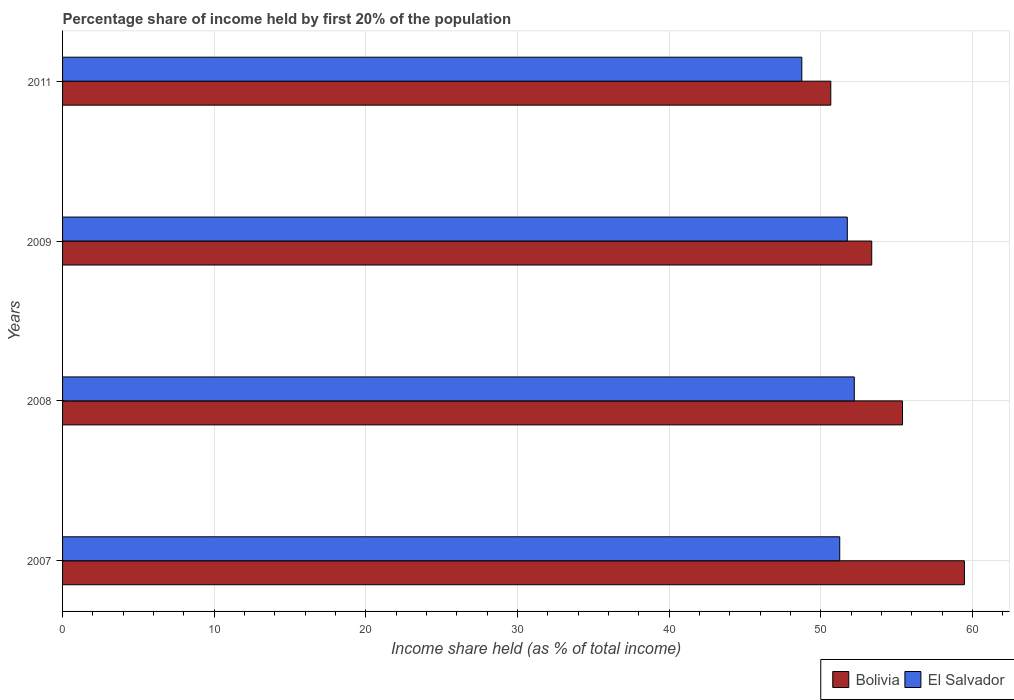How many groups of bars are there?
Ensure brevity in your answer.  4. How many bars are there on the 4th tick from the top?
Offer a very short reply. 2. How many bars are there on the 2nd tick from the bottom?
Your answer should be compact. 2. In how many cases, is the number of bars for a given year not equal to the number of legend labels?
Give a very brief answer. 0. What is the share of income held by first 20% of the population in El Salvador in 2007?
Keep it short and to the point. 51.24. Across all years, what is the maximum share of income held by first 20% of the population in El Salvador?
Offer a very short reply. 52.2. Across all years, what is the minimum share of income held by first 20% of the population in El Salvador?
Your answer should be compact. 48.74. What is the total share of income held by first 20% of the population in Bolivia in the graph?
Your response must be concise. 218.84. What is the difference between the share of income held by first 20% of the population in El Salvador in 2009 and that in 2011?
Provide a short and direct response. 3. What is the difference between the share of income held by first 20% of the population in El Salvador in 2009 and the share of income held by first 20% of the population in Bolivia in 2008?
Ensure brevity in your answer.  -3.64. What is the average share of income held by first 20% of the population in Bolivia per year?
Provide a short and direct response. 54.71. In the year 2009, what is the difference between the share of income held by first 20% of the population in Bolivia and share of income held by first 20% of the population in El Salvador?
Offer a very short reply. 1.61. In how many years, is the share of income held by first 20% of the population in El Salvador greater than 46 %?
Keep it short and to the point. 4. What is the ratio of the share of income held by first 20% of the population in Bolivia in 2008 to that in 2011?
Give a very brief answer. 1.09. Is the share of income held by first 20% of the population in El Salvador in 2007 less than that in 2008?
Your response must be concise. Yes. What is the difference between the highest and the second highest share of income held by first 20% of the population in Bolivia?
Provide a succinct answer. 4.08. What is the difference between the highest and the lowest share of income held by first 20% of the population in Bolivia?
Ensure brevity in your answer.  8.81. Is the sum of the share of income held by first 20% of the population in Bolivia in 2009 and 2011 greater than the maximum share of income held by first 20% of the population in El Salvador across all years?
Your answer should be very brief. Yes. What does the 2nd bar from the top in 2007 represents?
Your response must be concise. Bolivia. How many years are there in the graph?
Provide a short and direct response. 4. Are the values on the major ticks of X-axis written in scientific E-notation?
Keep it short and to the point. No. Does the graph contain any zero values?
Provide a short and direct response. No. Does the graph contain grids?
Keep it short and to the point. Yes. Where does the legend appear in the graph?
Ensure brevity in your answer.  Bottom right. How many legend labels are there?
Provide a succinct answer. 2. What is the title of the graph?
Your answer should be compact. Percentage share of income held by first 20% of the population. What is the label or title of the X-axis?
Your response must be concise. Income share held (as % of total income). What is the Income share held (as % of total income) in Bolivia in 2007?
Your answer should be compact. 59.46. What is the Income share held (as % of total income) of El Salvador in 2007?
Provide a succinct answer. 51.24. What is the Income share held (as % of total income) in Bolivia in 2008?
Provide a succinct answer. 55.38. What is the Income share held (as % of total income) in El Salvador in 2008?
Provide a succinct answer. 52.2. What is the Income share held (as % of total income) in Bolivia in 2009?
Your answer should be very brief. 53.35. What is the Income share held (as % of total income) in El Salvador in 2009?
Your answer should be compact. 51.74. What is the Income share held (as % of total income) of Bolivia in 2011?
Your answer should be very brief. 50.65. What is the Income share held (as % of total income) in El Salvador in 2011?
Keep it short and to the point. 48.74. Across all years, what is the maximum Income share held (as % of total income) in Bolivia?
Offer a very short reply. 59.46. Across all years, what is the maximum Income share held (as % of total income) of El Salvador?
Provide a succinct answer. 52.2. Across all years, what is the minimum Income share held (as % of total income) in Bolivia?
Your answer should be compact. 50.65. Across all years, what is the minimum Income share held (as % of total income) of El Salvador?
Provide a short and direct response. 48.74. What is the total Income share held (as % of total income) in Bolivia in the graph?
Your response must be concise. 218.84. What is the total Income share held (as % of total income) of El Salvador in the graph?
Offer a terse response. 203.92. What is the difference between the Income share held (as % of total income) in Bolivia in 2007 and that in 2008?
Provide a short and direct response. 4.08. What is the difference between the Income share held (as % of total income) of El Salvador in 2007 and that in 2008?
Your answer should be compact. -0.96. What is the difference between the Income share held (as % of total income) in Bolivia in 2007 and that in 2009?
Provide a short and direct response. 6.11. What is the difference between the Income share held (as % of total income) in El Salvador in 2007 and that in 2009?
Make the answer very short. -0.5. What is the difference between the Income share held (as % of total income) in Bolivia in 2007 and that in 2011?
Make the answer very short. 8.81. What is the difference between the Income share held (as % of total income) of Bolivia in 2008 and that in 2009?
Provide a short and direct response. 2.03. What is the difference between the Income share held (as % of total income) of El Salvador in 2008 and that in 2009?
Provide a short and direct response. 0.46. What is the difference between the Income share held (as % of total income) of Bolivia in 2008 and that in 2011?
Offer a very short reply. 4.73. What is the difference between the Income share held (as % of total income) in El Salvador in 2008 and that in 2011?
Keep it short and to the point. 3.46. What is the difference between the Income share held (as % of total income) of El Salvador in 2009 and that in 2011?
Provide a succinct answer. 3. What is the difference between the Income share held (as % of total income) in Bolivia in 2007 and the Income share held (as % of total income) in El Salvador in 2008?
Offer a very short reply. 7.26. What is the difference between the Income share held (as % of total income) in Bolivia in 2007 and the Income share held (as % of total income) in El Salvador in 2009?
Give a very brief answer. 7.72. What is the difference between the Income share held (as % of total income) in Bolivia in 2007 and the Income share held (as % of total income) in El Salvador in 2011?
Ensure brevity in your answer.  10.72. What is the difference between the Income share held (as % of total income) in Bolivia in 2008 and the Income share held (as % of total income) in El Salvador in 2009?
Offer a terse response. 3.64. What is the difference between the Income share held (as % of total income) in Bolivia in 2008 and the Income share held (as % of total income) in El Salvador in 2011?
Offer a very short reply. 6.64. What is the difference between the Income share held (as % of total income) of Bolivia in 2009 and the Income share held (as % of total income) of El Salvador in 2011?
Offer a very short reply. 4.61. What is the average Income share held (as % of total income) of Bolivia per year?
Your answer should be very brief. 54.71. What is the average Income share held (as % of total income) in El Salvador per year?
Your answer should be very brief. 50.98. In the year 2007, what is the difference between the Income share held (as % of total income) in Bolivia and Income share held (as % of total income) in El Salvador?
Offer a very short reply. 8.22. In the year 2008, what is the difference between the Income share held (as % of total income) in Bolivia and Income share held (as % of total income) in El Salvador?
Offer a very short reply. 3.18. In the year 2009, what is the difference between the Income share held (as % of total income) in Bolivia and Income share held (as % of total income) in El Salvador?
Give a very brief answer. 1.61. In the year 2011, what is the difference between the Income share held (as % of total income) in Bolivia and Income share held (as % of total income) in El Salvador?
Provide a short and direct response. 1.91. What is the ratio of the Income share held (as % of total income) of Bolivia in 2007 to that in 2008?
Your response must be concise. 1.07. What is the ratio of the Income share held (as % of total income) of El Salvador in 2007 to that in 2008?
Provide a succinct answer. 0.98. What is the ratio of the Income share held (as % of total income) of Bolivia in 2007 to that in 2009?
Make the answer very short. 1.11. What is the ratio of the Income share held (as % of total income) of El Salvador in 2007 to that in 2009?
Give a very brief answer. 0.99. What is the ratio of the Income share held (as % of total income) in Bolivia in 2007 to that in 2011?
Your answer should be very brief. 1.17. What is the ratio of the Income share held (as % of total income) in El Salvador in 2007 to that in 2011?
Give a very brief answer. 1.05. What is the ratio of the Income share held (as % of total income) in Bolivia in 2008 to that in 2009?
Offer a very short reply. 1.04. What is the ratio of the Income share held (as % of total income) of El Salvador in 2008 to that in 2009?
Keep it short and to the point. 1.01. What is the ratio of the Income share held (as % of total income) of Bolivia in 2008 to that in 2011?
Your answer should be very brief. 1.09. What is the ratio of the Income share held (as % of total income) of El Salvador in 2008 to that in 2011?
Your answer should be compact. 1.07. What is the ratio of the Income share held (as % of total income) in Bolivia in 2009 to that in 2011?
Offer a very short reply. 1.05. What is the ratio of the Income share held (as % of total income) of El Salvador in 2009 to that in 2011?
Make the answer very short. 1.06. What is the difference between the highest and the second highest Income share held (as % of total income) of Bolivia?
Provide a succinct answer. 4.08. What is the difference between the highest and the second highest Income share held (as % of total income) of El Salvador?
Offer a very short reply. 0.46. What is the difference between the highest and the lowest Income share held (as % of total income) of Bolivia?
Give a very brief answer. 8.81. What is the difference between the highest and the lowest Income share held (as % of total income) of El Salvador?
Your answer should be compact. 3.46. 